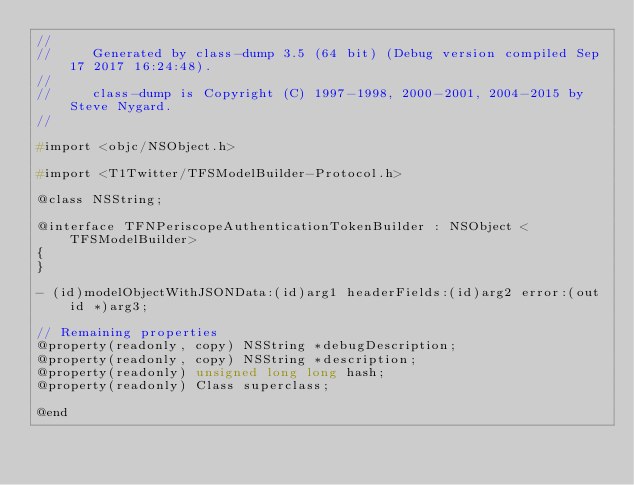Convert code to text. <code><loc_0><loc_0><loc_500><loc_500><_C_>//
//     Generated by class-dump 3.5 (64 bit) (Debug version compiled Sep 17 2017 16:24:48).
//
//     class-dump is Copyright (C) 1997-1998, 2000-2001, 2004-2015 by Steve Nygard.
//

#import <objc/NSObject.h>

#import <T1Twitter/TFSModelBuilder-Protocol.h>

@class NSString;

@interface TFNPeriscopeAuthenticationTokenBuilder : NSObject <TFSModelBuilder>
{
}

- (id)modelObjectWithJSONData:(id)arg1 headerFields:(id)arg2 error:(out id *)arg3;

// Remaining properties
@property(readonly, copy) NSString *debugDescription;
@property(readonly, copy) NSString *description;
@property(readonly) unsigned long long hash;
@property(readonly) Class superclass;

@end

</code> 